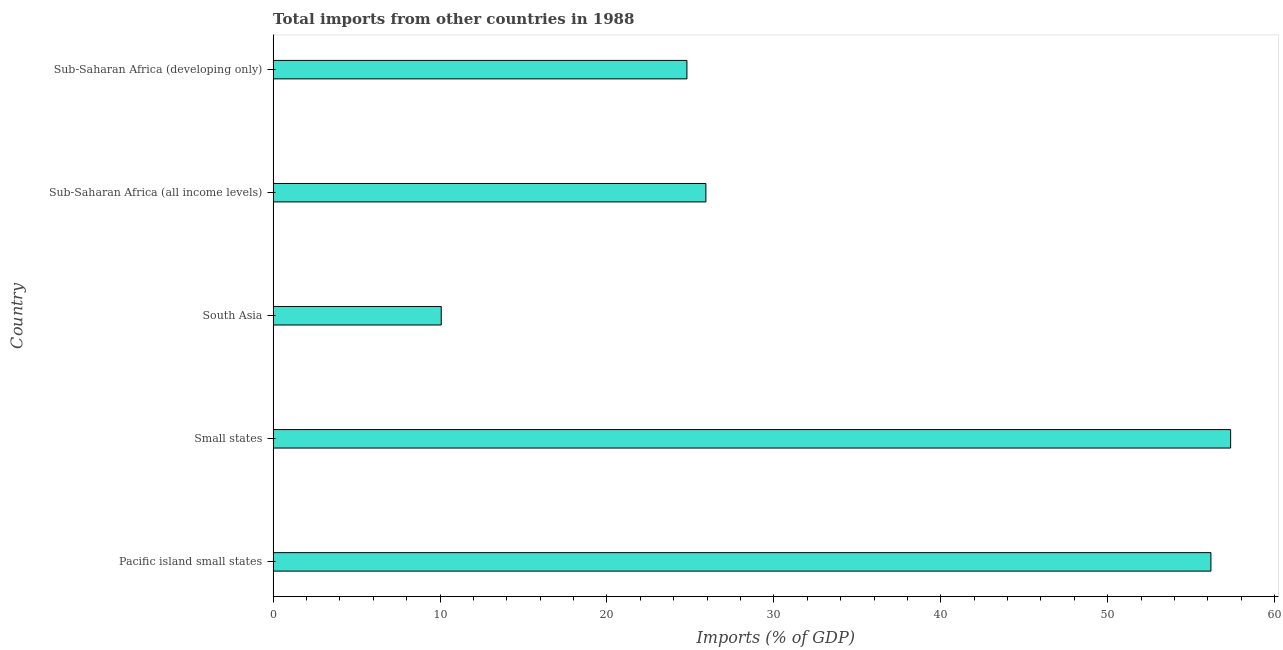Does the graph contain any zero values?
Your response must be concise. No. Does the graph contain grids?
Offer a very short reply. No. What is the title of the graph?
Keep it short and to the point. Total imports from other countries in 1988. What is the label or title of the X-axis?
Give a very brief answer. Imports (% of GDP). What is the label or title of the Y-axis?
Your response must be concise. Country. What is the total imports in Sub-Saharan Africa (developing only)?
Your answer should be compact. 24.79. Across all countries, what is the maximum total imports?
Give a very brief answer. 57.37. Across all countries, what is the minimum total imports?
Provide a succinct answer. 10.07. In which country was the total imports maximum?
Your answer should be compact. Small states. What is the sum of the total imports?
Give a very brief answer. 174.34. What is the difference between the total imports in Pacific island small states and Small states?
Make the answer very short. -1.18. What is the average total imports per country?
Ensure brevity in your answer.  34.87. What is the median total imports?
Your answer should be compact. 25.93. What is the ratio of the total imports in South Asia to that in Sub-Saharan Africa (developing only)?
Offer a very short reply. 0.41. Is the total imports in Pacific island small states less than that in Small states?
Your answer should be very brief. Yes. What is the difference between the highest and the second highest total imports?
Provide a short and direct response. 1.18. What is the difference between the highest and the lowest total imports?
Provide a short and direct response. 47.29. Are all the bars in the graph horizontal?
Keep it short and to the point. Yes. How many countries are there in the graph?
Make the answer very short. 5. What is the difference between two consecutive major ticks on the X-axis?
Your answer should be very brief. 10. Are the values on the major ticks of X-axis written in scientific E-notation?
Make the answer very short. No. What is the Imports (% of GDP) of Pacific island small states?
Offer a very short reply. 56.19. What is the Imports (% of GDP) in Small states?
Your answer should be very brief. 57.37. What is the Imports (% of GDP) of South Asia?
Your answer should be compact. 10.07. What is the Imports (% of GDP) in Sub-Saharan Africa (all income levels)?
Offer a terse response. 25.93. What is the Imports (% of GDP) in Sub-Saharan Africa (developing only)?
Provide a short and direct response. 24.79. What is the difference between the Imports (% of GDP) in Pacific island small states and Small states?
Ensure brevity in your answer.  -1.18. What is the difference between the Imports (% of GDP) in Pacific island small states and South Asia?
Keep it short and to the point. 46.11. What is the difference between the Imports (% of GDP) in Pacific island small states and Sub-Saharan Africa (all income levels)?
Your answer should be compact. 30.26. What is the difference between the Imports (% of GDP) in Pacific island small states and Sub-Saharan Africa (developing only)?
Make the answer very short. 31.39. What is the difference between the Imports (% of GDP) in Small states and South Asia?
Give a very brief answer. 47.29. What is the difference between the Imports (% of GDP) in Small states and Sub-Saharan Africa (all income levels)?
Provide a succinct answer. 31.44. What is the difference between the Imports (% of GDP) in Small states and Sub-Saharan Africa (developing only)?
Ensure brevity in your answer.  32.57. What is the difference between the Imports (% of GDP) in South Asia and Sub-Saharan Africa (all income levels)?
Provide a succinct answer. -15.86. What is the difference between the Imports (% of GDP) in South Asia and Sub-Saharan Africa (developing only)?
Give a very brief answer. -14.72. What is the difference between the Imports (% of GDP) in Sub-Saharan Africa (all income levels) and Sub-Saharan Africa (developing only)?
Provide a succinct answer. 1.14. What is the ratio of the Imports (% of GDP) in Pacific island small states to that in South Asia?
Keep it short and to the point. 5.58. What is the ratio of the Imports (% of GDP) in Pacific island small states to that in Sub-Saharan Africa (all income levels)?
Offer a very short reply. 2.17. What is the ratio of the Imports (% of GDP) in Pacific island small states to that in Sub-Saharan Africa (developing only)?
Ensure brevity in your answer.  2.27. What is the ratio of the Imports (% of GDP) in Small states to that in South Asia?
Give a very brief answer. 5.7. What is the ratio of the Imports (% of GDP) in Small states to that in Sub-Saharan Africa (all income levels)?
Offer a very short reply. 2.21. What is the ratio of the Imports (% of GDP) in Small states to that in Sub-Saharan Africa (developing only)?
Give a very brief answer. 2.31. What is the ratio of the Imports (% of GDP) in South Asia to that in Sub-Saharan Africa (all income levels)?
Your answer should be very brief. 0.39. What is the ratio of the Imports (% of GDP) in South Asia to that in Sub-Saharan Africa (developing only)?
Your answer should be very brief. 0.41. What is the ratio of the Imports (% of GDP) in Sub-Saharan Africa (all income levels) to that in Sub-Saharan Africa (developing only)?
Provide a short and direct response. 1.05. 